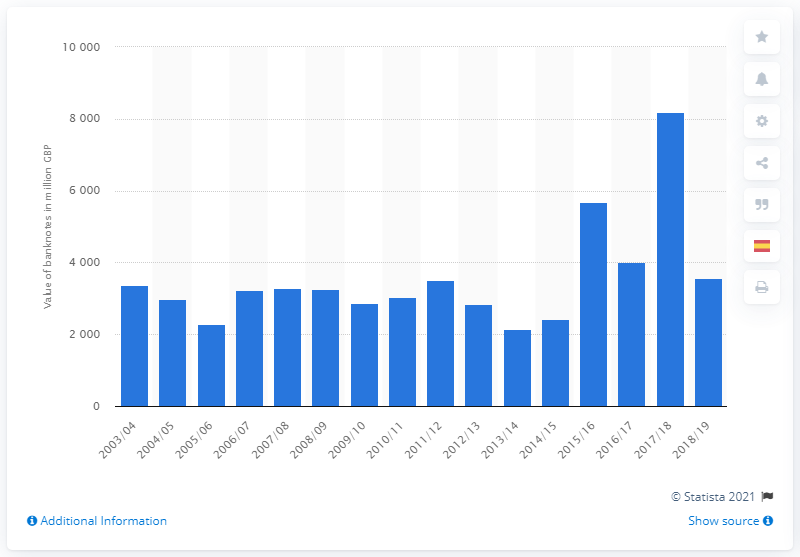Draw attention to some important aspects in this diagram. As of 2019, the total value of ten British pound banknotes issued was 3,520. 